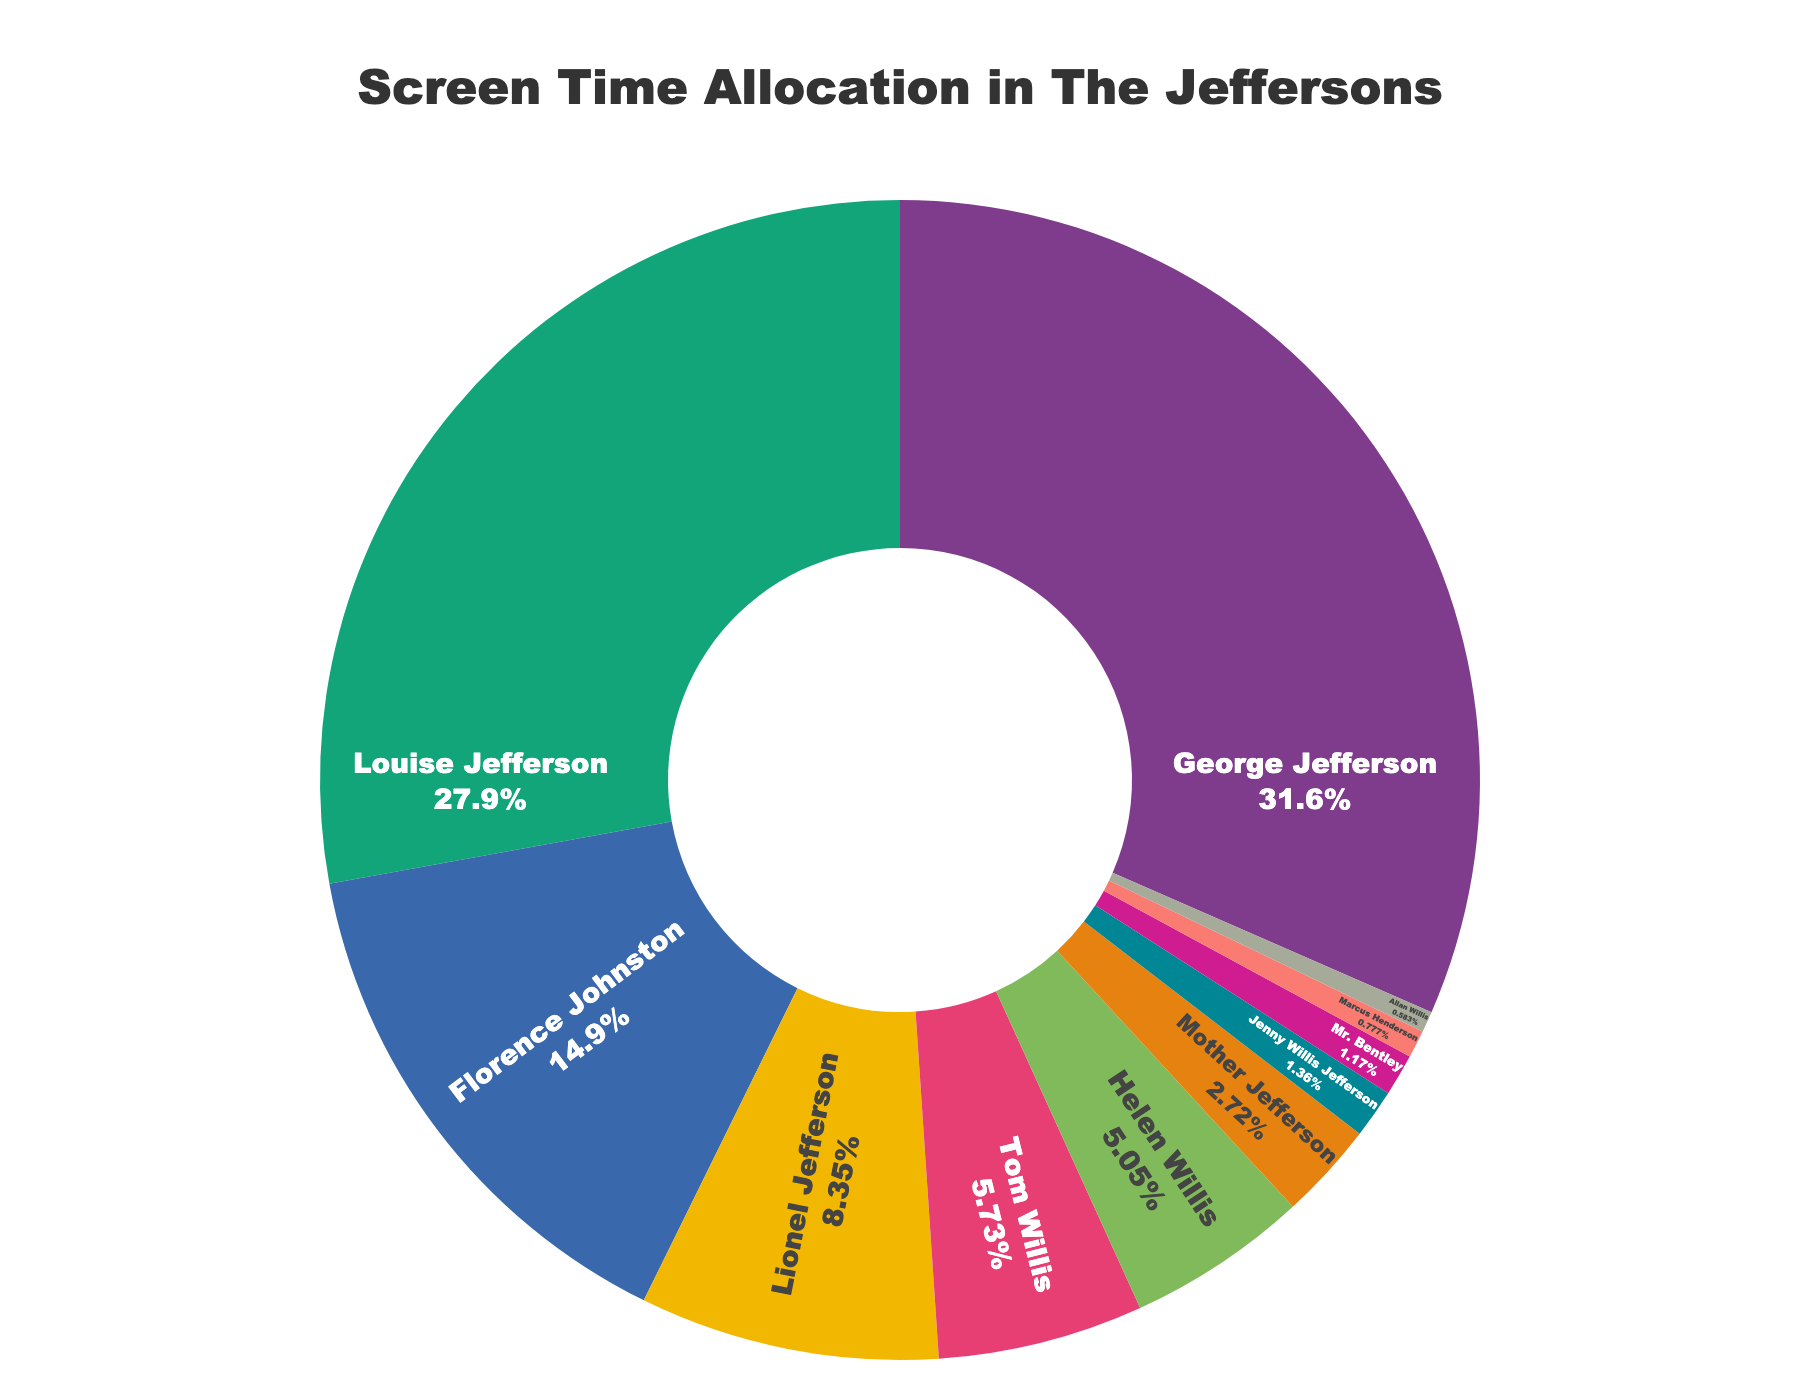Which character has the highest screen time percentage? The figure shows different characters and their respective screen time percentages. George Jefferson's segment is the largest, indicating the highest percentage.
Answer: George Jefferson What is the combined screen time percentage of Lionel Jefferson and Helen Willis? According to the figure, Lionel Jefferson has 8.6% and Helen Willis has 5.2%. Adding these together, the combined screen time percentage is 8.6% + 5.2% = 13.8%.
Answer: 13.8% How much more screen time does Florence Johnston have compared to Tom Willis? Florence Johnston has 15.3% screen time while Tom Willis has 5.9%. The difference is 15.3% - 5.9% = 9.4%.
Answer: 9.4% Compare the screen time percentages of Louise Jefferson and Florence Johnston. Which one is greater and by how much? Louise Jefferson has 28.7% screen time, while Florence Johnston has 15.3%. Louise’s screen time is greater by 28.7% - 15.3% = 13.4%.
Answer: Louise Jefferson, 13.4% What is the total screen time percentage for all the Jefferson family members combined? The Jefferson family members include George, Louise, Lionel, Mother Jefferson, and Jenny Willis Jefferson. Their respective screen times are 32.5%, 28.7%, 8.6%, 2.8%, and 1.4%. Summing these values gives: 32.5% + 28.7% + 8.6% + 2.8% + 1.4% = 74%.
Answer: 74% What percentage of the screen time is allocated to characters who have less than 10% screen time each? Characters with less than 10% screen time include Lionel Jefferson (8.6%), Tom Willis (5.9%), Helen Willis (5.2%), Mother Jefferson (2.8%), Jenny Willis Jefferson (1.4%), Mr. Bentley (1.2%), Marcus Henderson (0.8%), and Allan Willis (0.6%). Adding these together: 8.6% + 5.9% + 5.2% + 2.8% + 1.4% + 1.2% + 0.8% + 0.6% = 26.5%.
Answer: 26.5% Which character has the smallest screen time percentage, and what is this percentage? The figure shows that Allan Willis has the smallest screen time with 0.6%.
Answer: Allan Willis, 0.6% How does the screen time of Mr. Bentley compare to that of Marcus Henderson? Mr. Bentley has a screen time of 1.2%, while Marcus Henderson has 0.8%. Mr. Bentley has more screen time by 1.2% - 0.8% = 0.4%.
Answer: Mr. Bentley, 0.4% What are the visual differences in the way main characters and minor characters are represented in the pie chart? The main characters have larger segments in the donut chart, indicating higher percentages, and are displayed in more prominent positions. Minor characters have smaller segments and are positioned less centrally.
Answer: Larger segments for main characters, smaller for minor characters 